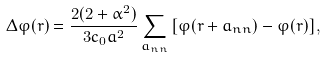<formula> <loc_0><loc_0><loc_500><loc_500>\Delta \varphi ( r ) = \frac { 2 ( 2 + \alpha ^ { 2 } ) } { 3 c _ { 0 } a ^ { 2 } } \sum _ { a _ { n n } } \left [ \varphi ( r + a _ { n n } ) - \varphi ( r ) \right ] ,</formula> 